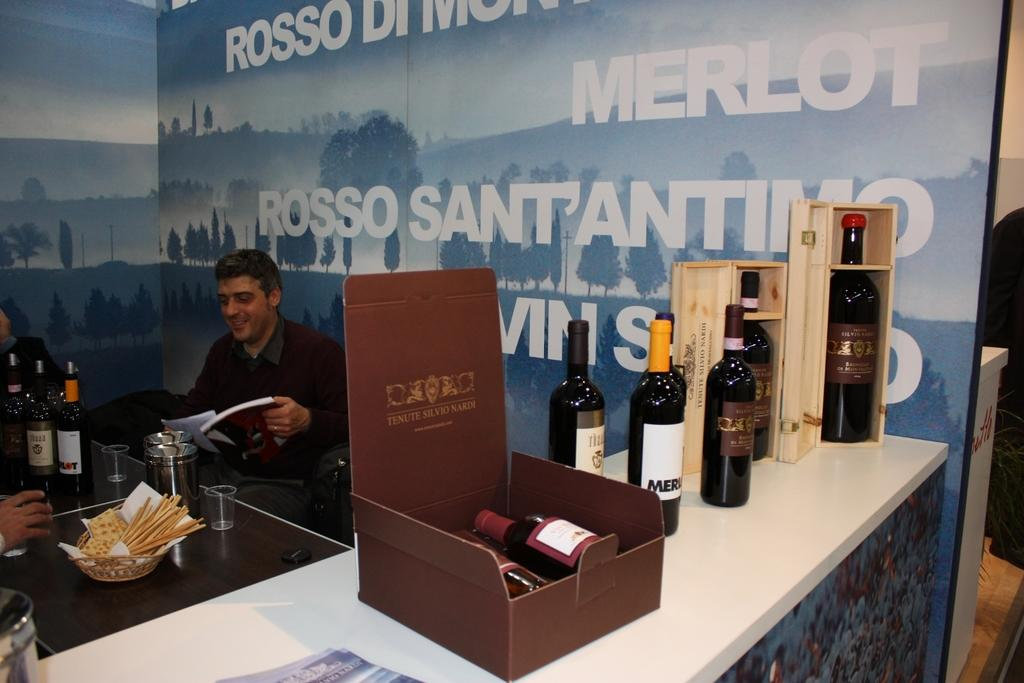Provide a one-sentence caption for the provided image. a few people sitting down with a merlot sign near them. 